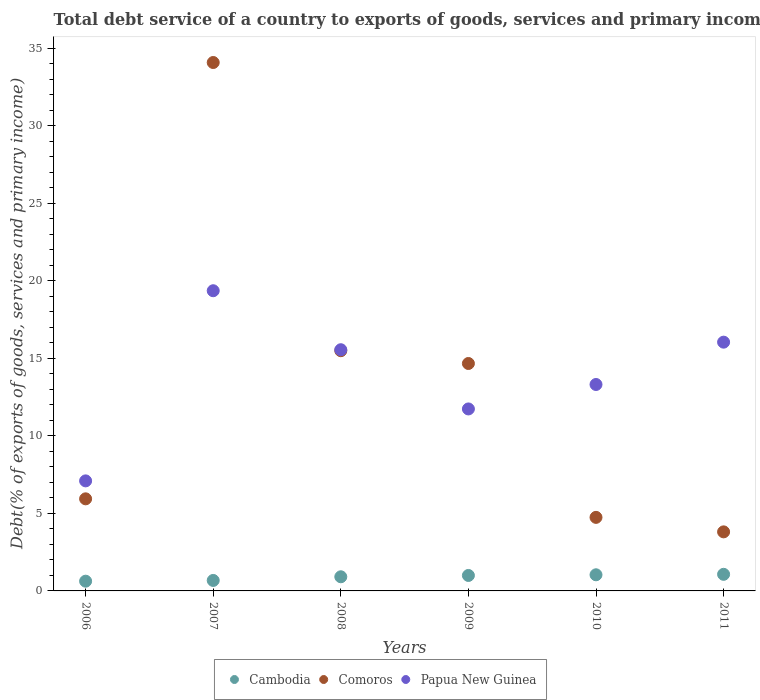Is the number of dotlines equal to the number of legend labels?
Keep it short and to the point. Yes. What is the total debt service in Papua New Guinea in 2011?
Give a very brief answer. 16.04. Across all years, what is the maximum total debt service in Papua New Guinea?
Provide a succinct answer. 19.36. Across all years, what is the minimum total debt service in Cambodia?
Offer a very short reply. 0.63. In which year was the total debt service in Comoros maximum?
Your answer should be compact. 2007. What is the total total debt service in Cambodia in the graph?
Offer a very short reply. 5.32. What is the difference between the total debt service in Comoros in 2009 and that in 2010?
Make the answer very short. 9.92. What is the difference between the total debt service in Papua New Guinea in 2011 and the total debt service in Cambodia in 2008?
Offer a terse response. 15.13. What is the average total debt service in Comoros per year?
Offer a very short reply. 13.12. In the year 2010, what is the difference between the total debt service in Comoros and total debt service in Cambodia?
Your answer should be compact. 3.7. In how many years, is the total debt service in Comoros greater than 3 %?
Your answer should be compact. 6. What is the ratio of the total debt service in Papua New Guinea in 2007 to that in 2010?
Make the answer very short. 1.45. What is the difference between the highest and the second highest total debt service in Cambodia?
Your response must be concise. 0.03. What is the difference between the highest and the lowest total debt service in Cambodia?
Provide a short and direct response. 0.44. Does the total debt service in Papua New Guinea monotonically increase over the years?
Your answer should be very brief. No. Is the total debt service in Cambodia strictly less than the total debt service in Comoros over the years?
Ensure brevity in your answer.  Yes. How many dotlines are there?
Offer a very short reply. 3. How many years are there in the graph?
Make the answer very short. 6. Does the graph contain grids?
Your response must be concise. No. How many legend labels are there?
Your response must be concise. 3. What is the title of the graph?
Your answer should be compact. Total debt service of a country to exports of goods, services and primary income. What is the label or title of the Y-axis?
Your answer should be compact. Debt(% of exports of goods, services and primary income). What is the Debt(% of exports of goods, services and primary income) of Cambodia in 2006?
Provide a short and direct response. 0.63. What is the Debt(% of exports of goods, services and primary income) of Comoros in 2006?
Your answer should be compact. 5.94. What is the Debt(% of exports of goods, services and primary income) in Papua New Guinea in 2006?
Ensure brevity in your answer.  7.1. What is the Debt(% of exports of goods, services and primary income) of Cambodia in 2007?
Keep it short and to the point. 0.68. What is the Debt(% of exports of goods, services and primary income) of Comoros in 2007?
Your answer should be very brief. 34.08. What is the Debt(% of exports of goods, services and primary income) in Papua New Guinea in 2007?
Provide a succinct answer. 19.36. What is the Debt(% of exports of goods, services and primary income) of Cambodia in 2008?
Offer a very short reply. 0.91. What is the Debt(% of exports of goods, services and primary income) of Comoros in 2008?
Provide a short and direct response. 15.49. What is the Debt(% of exports of goods, services and primary income) in Papua New Guinea in 2008?
Make the answer very short. 15.56. What is the Debt(% of exports of goods, services and primary income) of Cambodia in 2009?
Provide a succinct answer. 1. What is the Debt(% of exports of goods, services and primary income) in Comoros in 2009?
Provide a succinct answer. 14.67. What is the Debt(% of exports of goods, services and primary income) in Papua New Guinea in 2009?
Provide a succinct answer. 11.74. What is the Debt(% of exports of goods, services and primary income) of Cambodia in 2010?
Provide a succinct answer. 1.04. What is the Debt(% of exports of goods, services and primary income) in Comoros in 2010?
Your answer should be very brief. 4.74. What is the Debt(% of exports of goods, services and primary income) in Papua New Guinea in 2010?
Make the answer very short. 13.31. What is the Debt(% of exports of goods, services and primary income) of Cambodia in 2011?
Offer a terse response. 1.07. What is the Debt(% of exports of goods, services and primary income) in Comoros in 2011?
Keep it short and to the point. 3.81. What is the Debt(% of exports of goods, services and primary income) of Papua New Guinea in 2011?
Provide a succinct answer. 16.04. Across all years, what is the maximum Debt(% of exports of goods, services and primary income) of Cambodia?
Make the answer very short. 1.07. Across all years, what is the maximum Debt(% of exports of goods, services and primary income) of Comoros?
Your answer should be compact. 34.08. Across all years, what is the maximum Debt(% of exports of goods, services and primary income) in Papua New Guinea?
Keep it short and to the point. 19.36. Across all years, what is the minimum Debt(% of exports of goods, services and primary income) of Cambodia?
Your answer should be compact. 0.63. Across all years, what is the minimum Debt(% of exports of goods, services and primary income) in Comoros?
Make the answer very short. 3.81. Across all years, what is the minimum Debt(% of exports of goods, services and primary income) in Papua New Guinea?
Keep it short and to the point. 7.1. What is the total Debt(% of exports of goods, services and primary income) of Cambodia in the graph?
Provide a succinct answer. 5.32. What is the total Debt(% of exports of goods, services and primary income) in Comoros in the graph?
Keep it short and to the point. 78.73. What is the total Debt(% of exports of goods, services and primary income) in Papua New Guinea in the graph?
Your answer should be compact. 83.11. What is the difference between the Debt(% of exports of goods, services and primary income) of Cambodia in 2006 and that in 2007?
Give a very brief answer. -0.05. What is the difference between the Debt(% of exports of goods, services and primary income) in Comoros in 2006 and that in 2007?
Your answer should be compact. -28.14. What is the difference between the Debt(% of exports of goods, services and primary income) of Papua New Guinea in 2006 and that in 2007?
Keep it short and to the point. -12.26. What is the difference between the Debt(% of exports of goods, services and primary income) of Cambodia in 2006 and that in 2008?
Offer a very short reply. -0.28. What is the difference between the Debt(% of exports of goods, services and primary income) in Comoros in 2006 and that in 2008?
Provide a succinct answer. -9.55. What is the difference between the Debt(% of exports of goods, services and primary income) in Papua New Guinea in 2006 and that in 2008?
Offer a terse response. -8.46. What is the difference between the Debt(% of exports of goods, services and primary income) of Cambodia in 2006 and that in 2009?
Make the answer very short. -0.37. What is the difference between the Debt(% of exports of goods, services and primary income) in Comoros in 2006 and that in 2009?
Your answer should be very brief. -8.73. What is the difference between the Debt(% of exports of goods, services and primary income) in Papua New Guinea in 2006 and that in 2009?
Make the answer very short. -4.64. What is the difference between the Debt(% of exports of goods, services and primary income) in Cambodia in 2006 and that in 2010?
Keep it short and to the point. -0.41. What is the difference between the Debt(% of exports of goods, services and primary income) in Comoros in 2006 and that in 2010?
Your answer should be compact. 1.2. What is the difference between the Debt(% of exports of goods, services and primary income) in Papua New Guinea in 2006 and that in 2010?
Provide a short and direct response. -6.22. What is the difference between the Debt(% of exports of goods, services and primary income) of Cambodia in 2006 and that in 2011?
Make the answer very short. -0.44. What is the difference between the Debt(% of exports of goods, services and primary income) in Comoros in 2006 and that in 2011?
Ensure brevity in your answer.  2.13. What is the difference between the Debt(% of exports of goods, services and primary income) of Papua New Guinea in 2006 and that in 2011?
Ensure brevity in your answer.  -8.95. What is the difference between the Debt(% of exports of goods, services and primary income) in Cambodia in 2007 and that in 2008?
Give a very brief answer. -0.24. What is the difference between the Debt(% of exports of goods, services and primary income) of Comoros in 2007 and that in 2008?
Your response must be concise. 18.59. What is the difference between the Debt(% of exports of goods, services and primary income) of Papua New Guinea in 2007 and that in 2008?
Offer a very short reply. 3.8. What is the difference between the Debt(% of exports of goods, services and primary income) of Cambodia in 2007 and that in 2009?
Your response must be concise. -0.32. What is the difference between the Debt(% of exports of goods, services and primary income) of Comoros in 2007 and that in 2009?
Your answer should be very brief. 19.41. What is the difference between the Debt(% of exports of goods, services and primary income) of Papua New Guinea in 2007 and that in 2009?
Offer a very short reply. 7.62. What is the difference between the Debt(% of exports of goods, services and primary income) in Cambodia in 2007 and that in 2010?
Provide a succinct answer. -0.37. What is the difference between the Debt(% of exports of goods, services and primary income) of Comoros in 2007 and that in 2010?
Make the answer very short. 29.34. What is the difference between the Debt(% of exports of goods, services and primary income) of Papua New Guinea in 2007 and that in 2010?
Provide a succinct answer. 6.05. What is the difference between the Debt(% of exports of goods, services and primary income) of Cambodia in 2007 and that in 2011?
Offer a very short reply. -0.4. What is the difference between the Debt(% of exports of goods, services and primary income) of Comoros in 2007 and that in 2011?
Your answer should be very brief. 30.27. What is the difference between the Debt(% of exports of goods, services and primary income) of Papua New Guinea in 2007 and that in 2011?
Keep it short and to the point. 3.32. What is the difference between the Debt(% of exports of goods, services and primary income) in Cambodia in 2008 and that in 2009?
Make the answer very short. -0.09. What is the difference between the Debt(% of exports of goods, services and primary income) in Comoros in 2008 and that in 2009?
Your answer should be very brief. 0.82. What is the difference between the Debt(% of exports of goods, services and primary income) of Papua New Guinea in 2008 and that in 2009?
Your answer should be very brief. 3.82. What is the difference between the Debt(% of exports of goods, services and primary income) in Cambodia in 2008 and that in 2010?
Keep it short and to the point. -0.13. What is the difference between the Debt(% of exports of goods, services and primary income) of Comoros in 2008 and that in 2010?
Ensure brevity in your answer.  10.75. What is the difference between the Debt(% of exports of goods, services and primary income) in Papua New Guinea in 2008 and that in 2010?
Your answer should be very brief. 2.24. What is the difference between the Debt(% of exports of goods, services and primary income) in Cambodia in 2008 and that in 2011?
Provide a succinct answer. -0.16. What is the difference between the Debt(% of exports of goods, services and primary income) in Comoros in 2008 and that in 2011?
Your answer should be very brief. 11.68. What is the difference between the Debt(% of exports of goods, services and primary income) of Papua New Guinea in 2008 and that in 2011?
Make the answer very short. -0.49. What is the difference between the Debt(% of exports of goods, services and primary income) of Cambodia in 2009 and that in 2010?
Ensure brevity in your answer.  -0.04. What is the difference between the Debt(% of exports of goods, services and primary income) in Comoros in 2009 and that in 2010?
Provide a short and direct response. 9.92. What is the difference between the Debt(% of exports of goods, services and primary income) in Papua New Guinea in 2009 and that in 2010?
Your answer should be compact. -1.58. What is the difference between the Debt(% of exports of goods, services and primary income) in Cambodia in 2009 and that in 2011?
Make the answer very short. -0.07. What is the difference between the Debt(% of exports of goods, services and primary income) of Comoros in 2009 and that in 2011?
Give a very brief answer. 10.86. What is the difference between the Debt(% of exports of goods, services and primary income) in Papua New Guinea in 2009 and that in 2011?
Your answer should be compact. -4.31. What is the difference between the Debt(% of exports of goods, services and primary income) of Cambodia in 2010 and that in 2011?
Make the answer very short. -0.03. What is the difference between the Debt(% of exports of goods, services and primary income) in Comoros in 2010 and that in 2011?
Provide a succinct answer. 0.93. What is the difference between the Debt(% of exports of goods, services and primary income) in Papua New Guinea in 2010 and that in 2011?
Ensure brevity in your answer.  -2.73. What is the difference between the Debt(% of exports of goods, services and primary income) in Cambodia in 2006 and the Debt(% of exports of goods, services and primary income) in Comoros in 2007?
Your response must be concise. -33.45. What is the difference between the Debt(% of exports of goods, services and primary income) of Cambodia in 2006 and the Debt(% of exports of goods, services and primary income) of Papua New Guinea in 2007?
Ensure brevity in your answer.  -18.73. What is the difference between the Debt(% of exports of goods, services and primary income) in Comoros in 2006 and the Debt(% of exports of goods, services and primary income) in Papua New Guinea in 2007?
Provide a succinct answer. -13.42. What is the difference between the Debt(% of exports of goods, services and primary income) of Cambodia in 2006 and the Debt(% of exports of goods, services and primary income) of Comoros in 2008?
Provide a short and direct response. -14.86. What is the difference between the Debt(% of exports of goods, services and primary income) in Cambodia in 2006 and the Debt(% of exports of goods, services and primary income) in Papua New Guinea in 2008?
Make the answer very short. -14.93. What is the difference between the Debt(% of exports of goods, services and primary income) in Comoros in 2006 and the Debt(% of exports of goods, services and primary income) in Papua New Guinea in 2008?
Ensure brevity in your answer.  -9.62. What is the difference between the Debt(% of exports of goods, services and primary income) in Cambodia in 2006 and the Debt(% of exports of goods, services and primary income) in Comoros in 2009?
Keep it short and to the point. -14.04. What is the difference between the Debt(% of exports of goods, services and primary income) in Cambodia in 2006 and the Debt(% of exports of goods, services and primary income) in Papua New Guinea in 2009?
Give a very brief answer. -11.11. What is the difference between the Debt(% of exports of goods, services and primary income) in Comoros in 2006 and the Debt(% of exports of goods, services and primary income) in Papua New Guinea in 2009?
Ensure brevity in your answer.  -5.8. What is the difference between the Debt(% of exports of goods, services and primary income) of Cambodia in 2006 and the Debt(% of exports of goods, services and primary income) of Comoros in 2010?
Make the answer very short. -4.12. What is the difference between the Debt(% of exports of goods, services and primary income) in Cambodia in 2006 and the Debt(% of exports of goods, services and primary income) in Papua New Guinea in 2010?
Make the answer very short. -12.69. What is the difference between the Debt(% of exports of goods, services and primary income) of Comoros in 2006 and the Debt(% of exports of goods, services and primary income) of Papua New Guinea in 2010?
Offer a terse response. -7.37. What is the difference between the Debt(% of exports of goods, services and primary income) in Cambodia in 2006 and the Debt(% of exports of goods, services and primary income) in Comoros in 2011?
Your response must be concise. -3.18. What is the difference between the Debt(% of exports of goods, services and primary income) of Cambodia in 2006 and the Debt(% of exports of goods, services and primary income) of Papua New Guinea in 2011?
Provide a succinct answer. -15.42. What is the difference between the Debt(% of exports of goods, services and primary income) of Comoros in 2006 and the Debt(% of exports of goods, services and primary income) of Papua New Guinea in 2011?
Your answer should be compact. -10.1. What is the difference between the Debt(% of exports of goods, services and primary income) in Cambodia in 2007 and the Debt(% of exports of goods, services and primary income) in Comoros in 2008?
Keep it short and to the point. -14.82. What is the difference between the Debt(% of exports of goods, services and primary income) in Cambodia in 2007 and the Debt(% of exports of goods, services and primary income) in Papua New Guinea in 2008?
Make the answer very short. -14.88. What is the difference between the Debt(% of exports of goods, services and primary income) of Comoros in 2007 and the Debt(% of exports of goods, services and primary income) of Papua New Guinea in 2008?
Offer a very short reply. 18.52. What is the difference between the Debt(% of exports of goods, services and primary income) of Cambodia in 2007 and the Debt(% of exports of goods, services and primary income) of Comoros in 2009?
Provide a short and direct response. -13.99. What is the difference between the Debt(% of exports of goods, services and primary income) in Cambodia in 2007 and the Debt(% of exports of goods, services and primary income) in Papua New Guinea in 2009?
Your answer should be very brief. -11.06. What is the difference between the Debt(% of exports of goods, services and primary income) in Comoros in 2007 and the Debt(% of exports of goods, services and primary income) in Papua New Guinea in 2009?
Provide a short and direct response. 22.34. What is the difference between the Debt(% of exports of goods, services and primary income) in Cambodia in 2007 and the Debt(% of exports of goods, services and primary income) in Comoros in 2010?
Your response must be concise. -4.07. What is the difference between the Debt(% of exports of goods, services and primary income) in Cambodia in 2007 and the Debt(% of exports of goods, services and primary income) in Papua New Guinea in 2010?
Your response must be concise. -12.64. What is the difference between the Debt(% of exports of goods, services and primary income) in Comoros in 2007 and the Debt(% of exports of goods, services and primary income) in Papua New Guinea in 2010?
Ensure brevity in your answer.  20.77. What is the difference between the Debt(% of exports of goods, services and primary income) in Cambodia in 2007 and the Debt(% of exports of goods, services and primary income) in Comoros in 2011?
Provide a succinct answer. -3.13. What is the difference between the Debt(% of exports of goods, services and primary income) in Cambodia in 2007 and the Debt(% of exports of goods, services and primary income) in Papua New Guinea in 2011?
Provide a short and direct response. -15.37. What is the difference between the Debt(% of exports of goods, services and primary income) of Comoros in 2007 and the Debt(% of exports of goods, services and primary income) of Papua New Guinea in 2011?
Offer a very short reply. 18.04. What is the difference between the Debt(% of exports of goods, services and primary income) of Cambodia in 2008 and the Debt(% of exports of goods, services and primary income) of Comoros in 2009?
Your response must be concise. -13.76. What is the difference between the Debt(% of exports of goods, services and primary income) in Cambodia in 2008 and the Debt(% of exports of goods, services and primary income) in Papua New Guinea in 2009?
Keep it short and to the point. -10.82. What is the difference between the Debt(% of exports of goods, services and primary income) in Comoros in 2008 and the Debt(% of exports of goods, services and primary income) in Papua New Guinea in 2009?
Your answer should be very brief. 3.76. What is the difference between the Debt(% of exports of goods, services and primary income) in Cambodia in 2008 and the Debt(% of exports of goods, services and primary income) in Comoros in 2010?
Your response must be concise. -3.83. What is the difference between the Debt(% of exports of goods, services and primary income) in Cambodia in 2008 and the Debt(% of exports of goods, services and primary income) in Papua New Guinea in 2010?
Ensure brevity in your answer.  -12.4. What is the difference between the Debt(% of exports of goods, services and primary income) of Comoros in 2008 and the Debt(% of exports of goods, services and primary income) of Papua New Guinea in 2010?
Keep it short and to the point. 2.18. What is the difference between the Debt(% of exports of goods, services and primary income) of Cambodia in 2008 and the Debt(% of exports of goods, services and primary income) of Comoros in 2011?
Offer a very short reply. -2.9. What is the difference between the Debt(% of exports of goods, services and primary income) in Cambodia in 2008 and the Debt(% of exports of goods, services and primary income) in Papua New Guinea in 2011?
Your answer should be compact. -15.13. What is the difference between the Debt(% of exports of goods, services and primary income) of Comoros in 2008 and the Debt(% of exports of goods, services and primary income) of Papua New Guinea in 2011?
Provide a short and direct response. -0.55. What is the difference between the Debt(% of exports of goods, services and primary income) of Cambodia in 2009 and the Debt(% of exports of goods, services and primary income) of Comoros in 2010?
Ensure brevity in your answer.  -3.75. What is the difference between the Debt(% of exports of goods, services and primary income) of Cambodia in 2009 and the Debt(% of exports of goods, services and primary income) of Papua New Guinea in 2010?
Make the answer very short. -12.32. What is the difference between the Debt(% of exports of goods, services and primary income) in Comoros in 2009 and the Debt(% of exports of goods, services and primary income) in Papua New Guinea in 2010?
Offer a terse response. 1.35. What is the difference between the Debt(% of exports of goods, services and primary income) of Cambodia in 2009 and the Debt(% of exports of goods, services and primary income) of Comoros in 2011?
Ensure brevity in your answer.  -2.81. What is the difference between the Debt(% of exports of goods, services and primary income) in Cambodia in 2009 and the Debt(% of exports of goods, services and primary income) in Papua New Guinea in 2011?
Offer a terse response. -15.05. What is the difference between the Debt(% of exports of goods, services and primary income) of Comoros in 2009 and the Debt(% of exports of goods, services and primary income) of Papua New Guinea in 2011?
Give a very brief answer. -1.38. What is the difference between the Debt(% of exports of goods, services and primary income) in Cambodia in 2010 and the Debt(% of exports of goods, services and primary income) in Comoros in 2011?
Ensure brevity in your answer.  -2.77. What is the difference between the Debt(% of exports of goods, services and primary income) in Cambodia in 2010 and the Debt(% of exports of goods, services and primary income) in Papua New Guinea in 2011?
Make the answer very short. -15. What is the difference between the Debt(% of exports of goods, services and primary income) of Comoros in 2010 and the Debt(% of exports of goods, services and primary income) of Papua New Guinea in 2011?
Make the answer very short. -11.3. What is the average Debt(% of exports of goods, services and primary income) in Cambodia per year?
Give a very brief answer. 0.89. What is the average Debt(% of exports of goods, services and primary income) of Comoros per year?
Offer a terse response. 13.12. What is the average Debt(% of exports of goods, services and primary income) of Papua New Guinea per year?
Offer a very short reply. 13.85. In the year 2006, what is the difference between the Debt(% of exports of goods, services and primary income) in Cambodia and Debt(% of exports of goods, services and primary income) in Comoros?
Your answer should be compact. -5.31. In the year 2006, what is the difference between the Debt(% of exports of goods, services and primary income) in Cambodia and Debt(% of exports of goods, services and primary income) in Papua New Guinea?
Provide a short and direct response. -6.47. In the year 2006, what is the difference between the Debt(% of exports of goods, services and primary income) of Comoros and Debt(% of exports of goods, services and primary income) of Papua New Guinea?
Your answer should be very brief. -1.16. In the year 2007, what is the difference between the Debt(% of exports of goods, services and primary income) of Cambodia and Debt(% of exports of goods, services and primary income) of Comoros?
Your response must be concise. -33.4. In the year 2007, what is the difference between the Debt(% of exports of goods, services and primary income) in Cambodia and Debt(% of exports of goods, services and primary income) in Papua New Guinea?
Your answer should be compact. -18.68. In the year 2007, what is the difference between the Debt(% of exports of goods, services and primary income) in Comoros and Debt(% of exports of goods, services and primary income) in Papua New Guinea?
Provide a succinct answer. 14.72. In the year 2008, what is the difference between the Debt(% of exports of goods, services and primary income) of Cambodia and Debt(% of exports of goods, services and primary income) of Comoros?
Ensure brevity in your answer.  -14.58. In the year 2008, what is the difference between the Debt(% of exports of goods, services and primary income) of Cambodia and Debt(% of exports of goods, services and primary income) of Papua New Guinea?
Your response must be concise. -14.64. In the year 2008, what is the difference between the Debt(% of exports of goods, services and primary income) of Comoros and Debt(% of exports of goods, services and primary income) of Papua New Guinea?
Offer a very short reply. -0.06. In the year 2009, what is the difference between the Debt(% of exports of goods, services and primary income) in Cambodia and Debt(% of exports of goods, services and primary income) in Comoros?
Your answer should be very brief. -13.67. In the year 2009, what is the difference between the Debt(% of exports of goods, services and primary income) of Cambodia and Debt(% of exports of goods, services and primary income) of Papua New Guinea?
Offer a terse response. -10.74. In the year 2009, what is the difference between the Debt(% of exports of goods, services and primary income) of Comoros and Debt(% of exports of goods, services and primary income) of Papua New Guinea?
Keep it short and to the point. 2.93. In the year 2010, what is the difference between the Debt(% of exports of goods, services and primary income) in Cambodia and Debt(% of exports of goods, services and primary income) in Comoros?
Make the answer very short. -3.7. In the year 2010, what is the difference between the Debt(% of exports of goods, services and primary income) of Cambodia and Debt(% of exports of goods, services and primary income) of Papua New Guinea?
Keep it short and to the point. -12.27. In the year 2010, what is the difference between the Debt(% of exports of goods, services and primary income) of Comoros and Debt(% of exports of goods, services and primary income) of Papua New Guinea?
Keep it short and to the point. -8.57. In the year 2011, what is the difference between the Debt(% of exports of goods, services and primary income) of Cambodia and Debt(% of exports of goods, services and primary income) of Comoros?
Give a very brief answer. -2.74. In the year 2011, what is the difference between the Debt(% of exports of goods, services and primary income) in Cambodia and Debt(% of exports of goods, services and primary income) in Papua New Guinea?
Your response must be concise. -14.97. In the year 2011, what is the difference between the Debt(% of exports of goods, services and primary income) in Comoros and Debt(% of exports of goods, services and primary income) in Papua New Guinea?
Offer a very short reply. -12.23. What is the ratio of the Debt(% of exports of goods, services and primary income) in Cambodia in 2006 to that in 2007?
Ensure brevity in your answer.  0.93. What is the ratio of the Debt(% of exports of goods, services and primary income) of Comoros in 2006 to that in 2007?
Provide a short and direct response. 0.17. What is the ratio of the Debt(% of exports of goods, services and primary income) in Papua New Guinea in 2006 to that in 2007?
Ensure brevity in your answer.  0.37. What is the ratio of the Debt(% of exports of goods, services and primary income) in Cambodia in 2006 to that in 2008?
Your response must be concise. 0.69. What is the ratio of the Debt(% of exports of goods, services and primary income) in Comoros in 2006 to that in 2008?
Keep it short and to the point. 0.38. What is the ratio of the Debt(% of exports of goods, services and primary income) in Papua New Guinea in 2006 to that in 2008?
Your response must be concise. 0.46. What is the ratio of the Debt(% of exports of goods, services and primary income) in Cambodia in 2006 to that in 2009?
Make the answer very short. 0.63. What is the ratio of the Debt(% of exports of goods, services and primary income) of Comoros in 2006 to that in 2009?
Your answer should be compact. 0.4. What is the ratio of the Debt(% of exports of goods, services and primary income) of Papua New Guinea in 2006 to that in 2009?
Offer a terse response. 0.6. What is the ratio of the Debt(% of exports of goods, services and primary income) in Cambodia in 2006 to that in 2010?
Provide a short and direct response. 0.6. What is the ratio of the Debt(% of exports of goods, services and primary income) of Comoros in 2006 to that in 2010?
Provide a succinct answer. 1.25. What is the ratio of the Debt(% of exports of goods, services and primary income) in Papua New Guinea in 2006 to that in 2010?
Provide a short and direct response. 0.53. What is the ratio of the Debt(% of exports of goods, services and primary income) in Cambodia in 2006 to that in 2011?
Your response must be concise. 0.59. What is the ratio of the Debt(% of exports of goods, services and primary income) in Comoros in 2006 to that in 2011?
Provide a succinct answer. 1.56. What is the ratio of the Debt(% of exports of goods, services and primary income) of Papua New Guinea in 2006 to that in 2011?
Your response must be concise. 0.44. What is the ratio of the Debt(% of exports of goods, services and primary income) in Cambodia in 2007 to that in 2008?
Your answer should be compact. 0.74. What is the ratio of the Debt(% of exports of goods, services and primary income) of Comoros in 2007 to that in 2008?
Provide a short and direct response. 2.2. What is the ratio of the Debt(% of exports of goods, services and primary income) in Papua New Guinea in 2007 to that in 2008?
Ensure brevity in your answer.  1.24. What is the ratio of the Debt(% of exports of goods, services and primary income) of Cambodia in 2007 to that in 2009?
Your response must be concise. 0.68. What is the ratio of the Debt(% of exports of goods, services and primary income) in Comoros in 2007 to that in 2009?
Your response must be concise. 2.32. What is the ratio of the Debt(% of exports of goods, services and primary income) in Papua New Guinea in 2007 to that in 2009?
Provide a succinct answer. 1.65. What is the ratio of the Debt(% of exports of goods, services and primary income) in Cambodia in 2007 to that in 2010?
Your answer should be very brief. 0.65. What is the ratio of the Debt(% of exports of goods, services and primary income) of Comoros in 2007 to that in 2010?
Give a very brief answer. 7.18. What is the ratio of the Debt(% of exports of goods, services and primary income) of Papua New Guinea in 2007 to that in 2010?
Offer a very short reply. 1.45. What is the ratio of the Debt(% of exports of goods, services and primary income) in Cambodia in 2007 to that in 2011?
Offer a terse response. 0.63. What is the ratio of the Debt(% of exports of goods, services and primary income) of Comoros in 2007 to that in 2011?
Keep it short and to the point. 8.95. What is the ratio of the Debt(% of exports of goods, services and primary income) of Papua New Guinea in 2007 to that in 2011?
Ensure brevity in your answer.  1.21. What is the ratio of the Debt(% of exports of goods, services and primary income) in Cambodia in 2008 to that in 2009?
Ensure brevity in your answer.  0.91. What is the ratio of the Debt(% of exports of goods, services and primary income) of Comoros in 2008 to that in 2009?
Give a very brief answer. 1.06. What is the ratio of the Debt(% of exports of goods, services and primary income) of Papua New Guinea in 2008 to that in 2009?
Your answer should be very brief. 1.33. What is the ratio of the Debt(% of exports of goods, services and primary income) in Cambodia in 2008 to that in 2010?
Offer a very short reply. 0.88. What is the ratio of the Debt(% of exports of goods, services and primary income) of Comoros in 2008 to that in 2010?
Your answer should be compact. 3.27. What is the ratio of the Debt(% of exports of goods, services and primary income) of Papua New Guinea in 2008 to that in 2010?
Your answer should be compact. 1.17. What is the ratio of the Debt(% of exports of goods, services and primary income) in Cambodia in 2008 to that in 2011?
Your response must be concise. 0.85. What is the ratio of the Debt(% of exports of goods, services and primary income) of Comoros in 2008 to that in 2011?
Provide a succinct answer. 4.07. What is the ratio of the Debt(% of exports of goods, services and primary income) in Papua New Guinea in 2008 to that in 2011?
Your answer should be compact. 0.97. What is the ratio of the Debt(% of exports of goods, services and primary income) of Cambodia in 2009 to that in 2010?
Your answer should be compact. 0.96. What is the ratio of the Debt(% of exports of goods, services and primary income) of Comoros in 2009 to that in 2010?
Your response must be concise. 3.09. What is the ratio of the Debt(% of exports of goods, services and primary income) in Papua New Guinea in 2009 to that in 2010?
Provide a succinct answer. 0.88. What is the ratio of the Debt(% of exports of goods, services and primary income) in Cambodia in 2009 to that in 2011?
Make the answer very short. 0.93. What is the ratio of the Debt(% of exports of goods, services and primary income) in Comoros in 2009 to that in 2011?
Provide a succinct answer. 3.85. What is the ratio of the Debt(% of exports of goods, services and primary income) in Papua New Guinea in 2009 to that in 2011?
Offer a very short reply. 0.73. What is the ratio of the Debt(% of exports of goods, services and primary income) in Cambodia in 2010 to that in 2011?
Keep it short and to the point. 0.97. What is the ratio of the Debt(% of exports of goods, services and primary income) in Comoros in 2010 to that in 2011?
Your answer should be compact. 1.25. What is the ratio of the Debt(% of exports of goods, services and primary income) in Papua New Guinea in 2010 to that in 2011?
Make the answer very short. 0.83. What is the difference between the highest and the second highest Debt(% of exports of goods, services and primary income) in Cambodia?
Your answer should be compact. 0.03. What is the difference between the highest and the second highest Debt(% of exports of goods, services and primary income) in Comoros?
Your answer should be very brief. 18.59. What is the difference between the highest and the second highest Debt(% of exports of goods, services and primary income) in Papua New Guinea?
Give a very brief answer. 3.32. What is the difference between the highest and the lowest Debt(% of exports of goods, services and primary income) in Cambodia?
Keep it short and to the point. 0.44. What is the difference between the highest and the lowest Debt(% of exports of goods, services and primary income) of Comoros?
Keep it short and to the point. 30.27. What is the difference between the highest and the lowest Debt(% of exports of goods, services and primary income) in Papua New Guinea?
Ensure brevity in your answer.  12.26. 